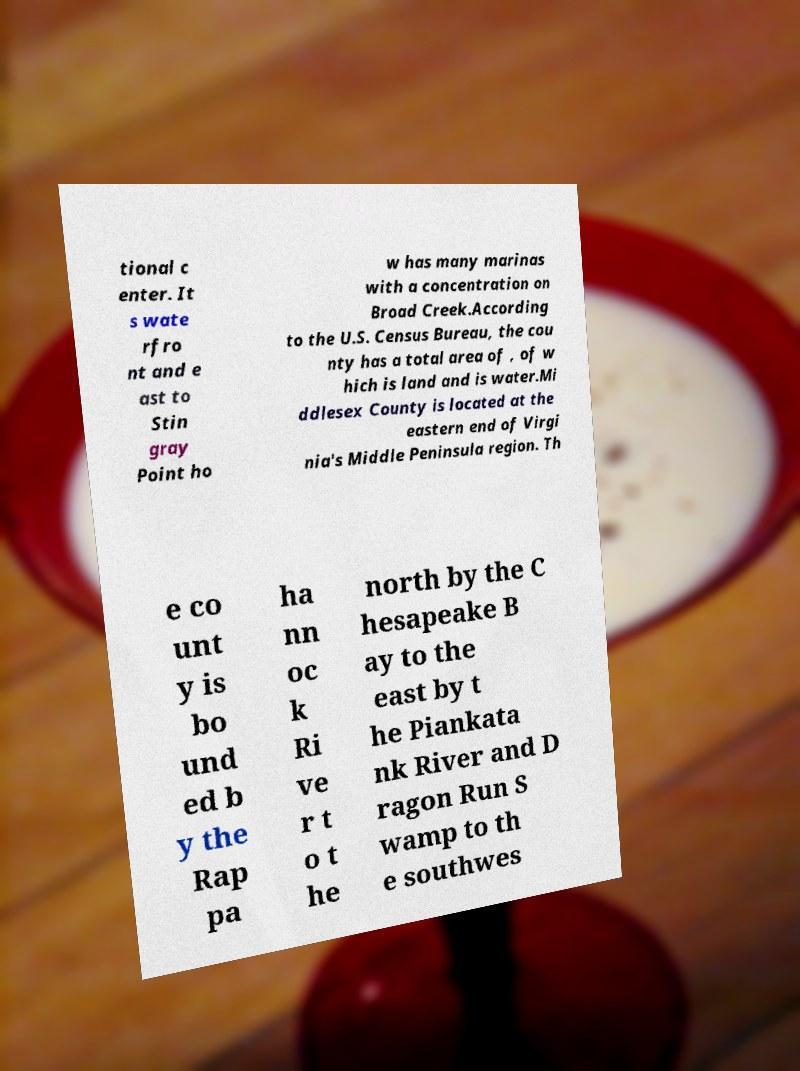Could you extract and type out the text from this image? tional c enter. It s wate rfro nt and e ast to Stin gray Point ho w has many marinas with a concentration on Broad Creek.According to the U.S. Census Bureau, the cou nty has a total area of , of w hich is land and is water.Mi ddlesex County is located at the eastern end of Virgi nia's Middle Peninsula region. Th e co unt y is bo und ed b y the Rap pa ha nn oc k Ri ve r t o t he north by the C hesapeake B ay to the east by t he Piankata nk River and D ragon Run S wamp to th e southwes 